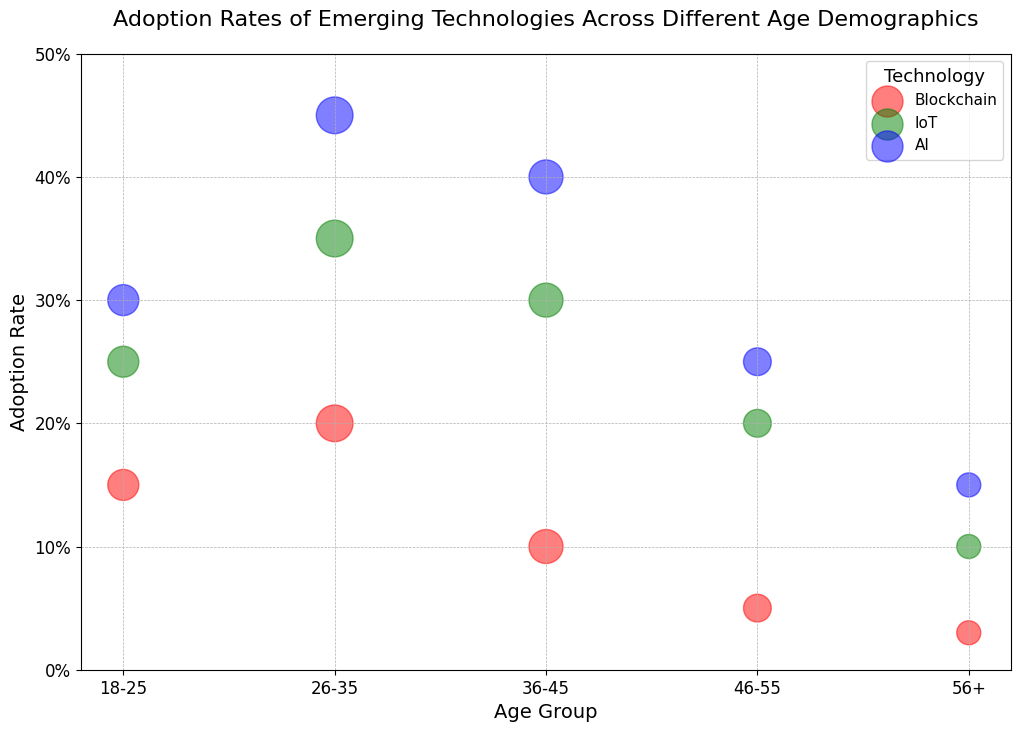Which age group has the highest adoption rate for AI? Look for the blue bubbles representing AI and find the highest position on the y-axis, which corresponds to the adoption rate.
Answer: 26-35 Which technology has the highest adoption rate in the 36-45 age group? Find the bubbles corresponding to the 36-45 age group and compare their vertical positions. The highest vertical position indicates the highest adoption rate.
Answer: AI How much larger is the adoption rate of IoT compared to Blockchain in the 26-35 age group? For the 26-35 age group, find the adoption rate of IoT (0.35) and Blockchain (0.20). Then subtract the Blockchain rate from the IoT rate.
Answer: 0.15 Which age group shows the most balanced adoption rates across all technologies? Compare the vertical positions (adoption rates) of red, green, and blue bubbles within each age group; the most balanced one will have smaller differences between these positions.
Answer: 46-55 What is the average adoption rate of Blockchain across all age groups? Sum the Blockchain adoption rates (0.15 + 0.20 + 0.10 + 0.05 + 0.03) and divide by the number of age groups (5).
Answer: 0.11 For the 56+ age group, which technology has the largest population size? Look at the size of the bubbles in the 56+ age group and identify the largest one.
Answer: All technologies have the same population size Compare the adoption rates of all three technologies in the 18-25 age group. Which one has the highest rate? Inspect the bubbles within the 18-25 age group and find the one with the highest vertical position.
Answer: AI What is the total adoption rate of AI across all age groups? Sum the AI adoption rates for all age groups (0.30 + 0.45 + 0.40 + 0.25 + 0.15).
Answer: 1.55 Which technology shows a decreasing trend in adoption rate as age increases? Evaluate the trend of the adoption rates for each technology bubble across the age groups.
Answer: AI Is there any age group where technology adoption rates are below 10% for all technologies? Check the adoption rates for all technologies in each age group and see if any age group has all rates below 0.10.
Answer: 56+ 